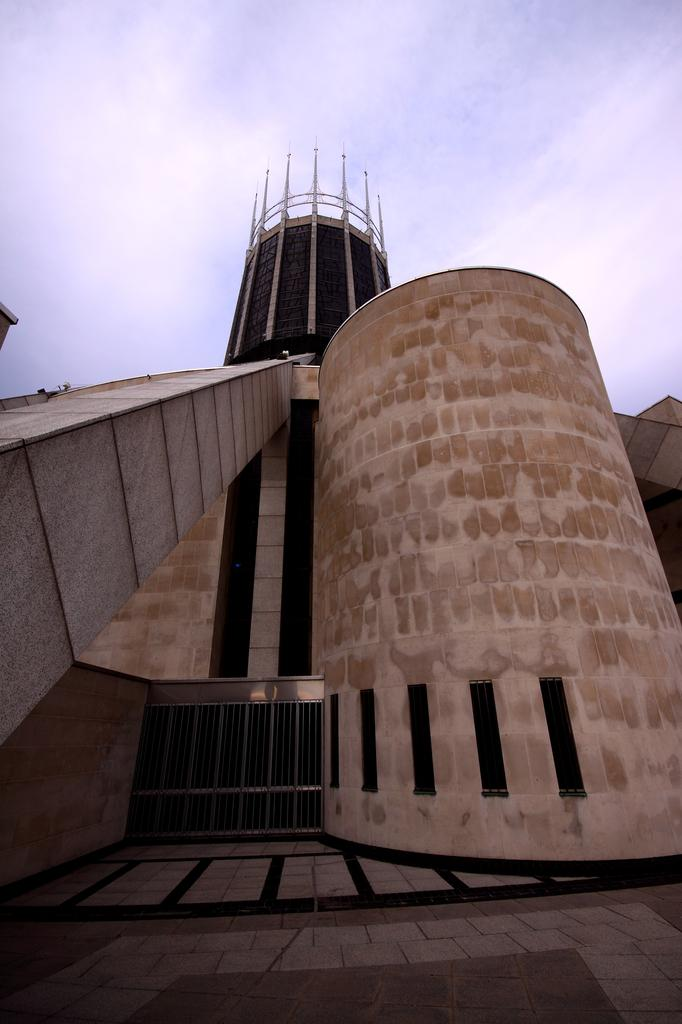What type of structure is present in the image? There is a building in the image. What can be seen in the foreground of the image? There is a railing in the foreground of the image. What is visible at the top of the image? The sky is visible at the top of the image. What can be observed in the sky? There are clouds in the sky. What type of art is being created by the yak in the image? There is no yak present in the image, and therefore no art being created by a yak. 